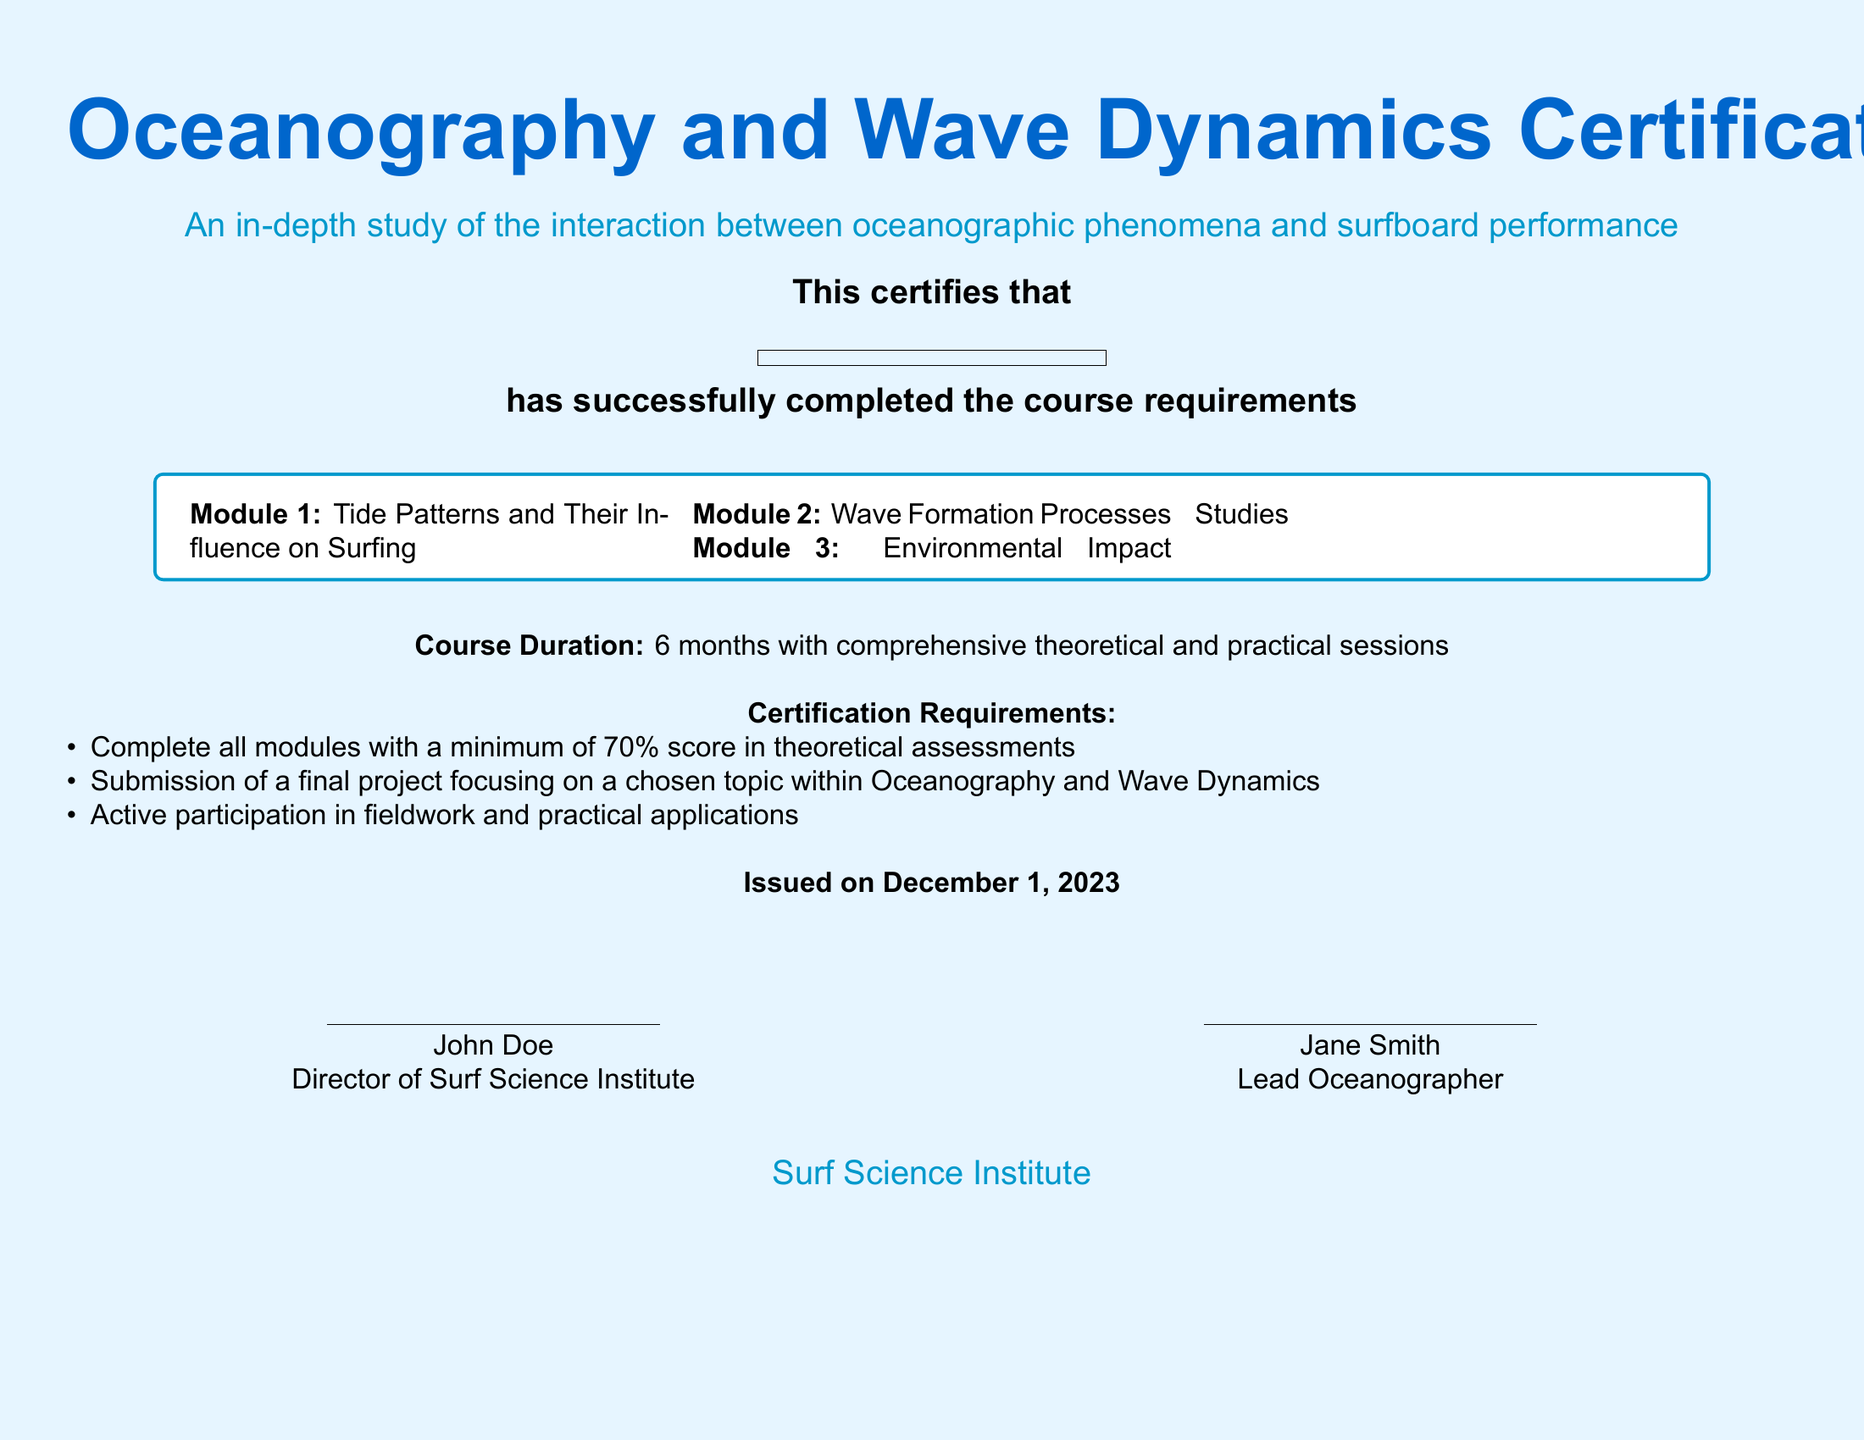What is the certification title? The title of the certification is explicitly stated at the top of the document, which is "Oceanography and Wave Dynamics Certification."
Answer: Oceanography and Wave Dynamics Certification Who is the issuing organization? The organization that issues the diploma is mentioned at the bottom of the document, identified as the "Surf Science Institute."
Answer: Surf Science Institute What is the course duration? The document specifies the duration of the course in the section regarding course details, indicating it lasts for "6 months."
Answer: 6 months What is the minimum passing score? The minimum score required for successful completion of the modules is outlined in the certification requirements section of the document as "70%."
Answer: 70% How many modules are included in the certification? The document lists the number of modules within the tcolorbox, which contains "3" modules.
Answer: 3 What is one of the topics covered in Module 2? The second module is titled "Wave Formation Processes," found in the list of modules, addressing a specific area of study.
Answer: Wave Formation Processes What is required for the final project? The certification requirements specify that a final project must focus on "a chosen topic within Oceanography and Wave Dynamics."
Answer: a chosen topic within Oceanography and Wave Dynamics Who are the directors mentioned in the document? The document lists two individuals in the signature section: John Doe and Jane Smith, whose titles are also provided.
Answer: John Doe, Jane Smith What is the issue date of the certification? The document provides the issue date of the certification in the designated section, which states "December 1, 2023."
Answer: December 1, 2023 